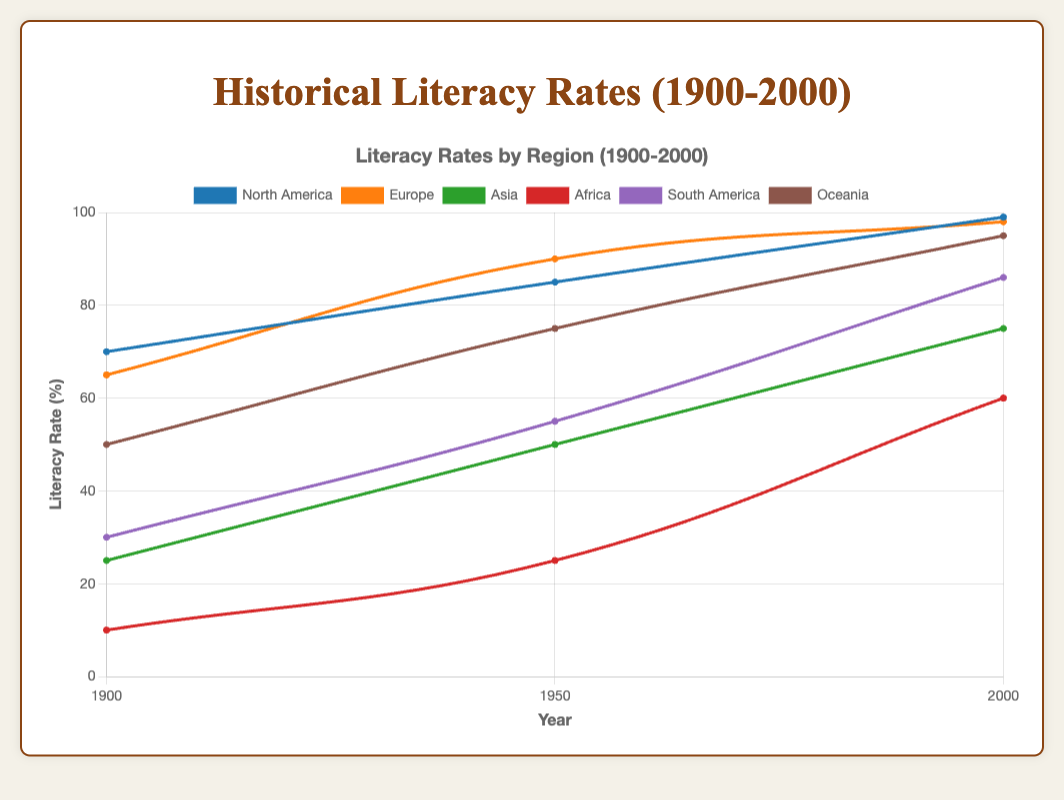What is the literacy rate of Europe in the year 2000? Look at the point on the line corresponding to Europe in the year 2000.
Answer: 98 Which region had the lowest literacy rate in 1900? Compare the literacy rates of all regions in 1900. Africa has the lowest rate at 10%.
Answer: Africa How much did the literacy rate in Asia increase from 1900 to 2000? Subtract the literacy rate in Asia in 1900 from the literacy rate in Asia in 2000: 75 - 25 = 50.
Answer: 50 Did North America or South America have a higher literacy rate in 1950? Compare the points for North America and South America in 1950. North America had 85, while South America had 55.
Answer: North America What was the average literacy rate across all regions in 1950? Calculate the average of the literacy rates in 1950 for all regions: (85 + 90 + 50 + 25 + 55 + 75) / 6 = 380 / 6 ≈ 63.33.
Answer: 63.33 Which region showed the greatest improvement in literacy rate from 1900 to 2000? Calculate the increase for each region, and find the region with the highest increase. Africa: 50, Asia: 50, Europe: 33, North America: 29, Oceania: 45, South America: 56.
Answer: South America By how many percent points did the literacy rate in Africa increase from 1950 to 2000? Subtract the literacy rate in Africa in 1950 from the rate in 2000: 60 - 25 = 35.
Answer: 35 Which region had the closest literacy rate to 75% in the year 2000? Identify the literacy rates in 2000 and compare them to 75. The closest are Asia (75), showing an exact match.
Answer: Asia Was the literacy rate in Oceania higher or lower than in Europe in 1900? Compare the points for Oceania and Europe in 1900. Oceania had 50, while Europe had 65.
Answer: Lower Which two regions had the largest difference in literacy rates in 2000? Calculate all pairwise differences for 2000 and find the maximum difference: The largest difference is between Africa (60) and North America (99), which is 39 percent points.
Answer: Africa and North America 